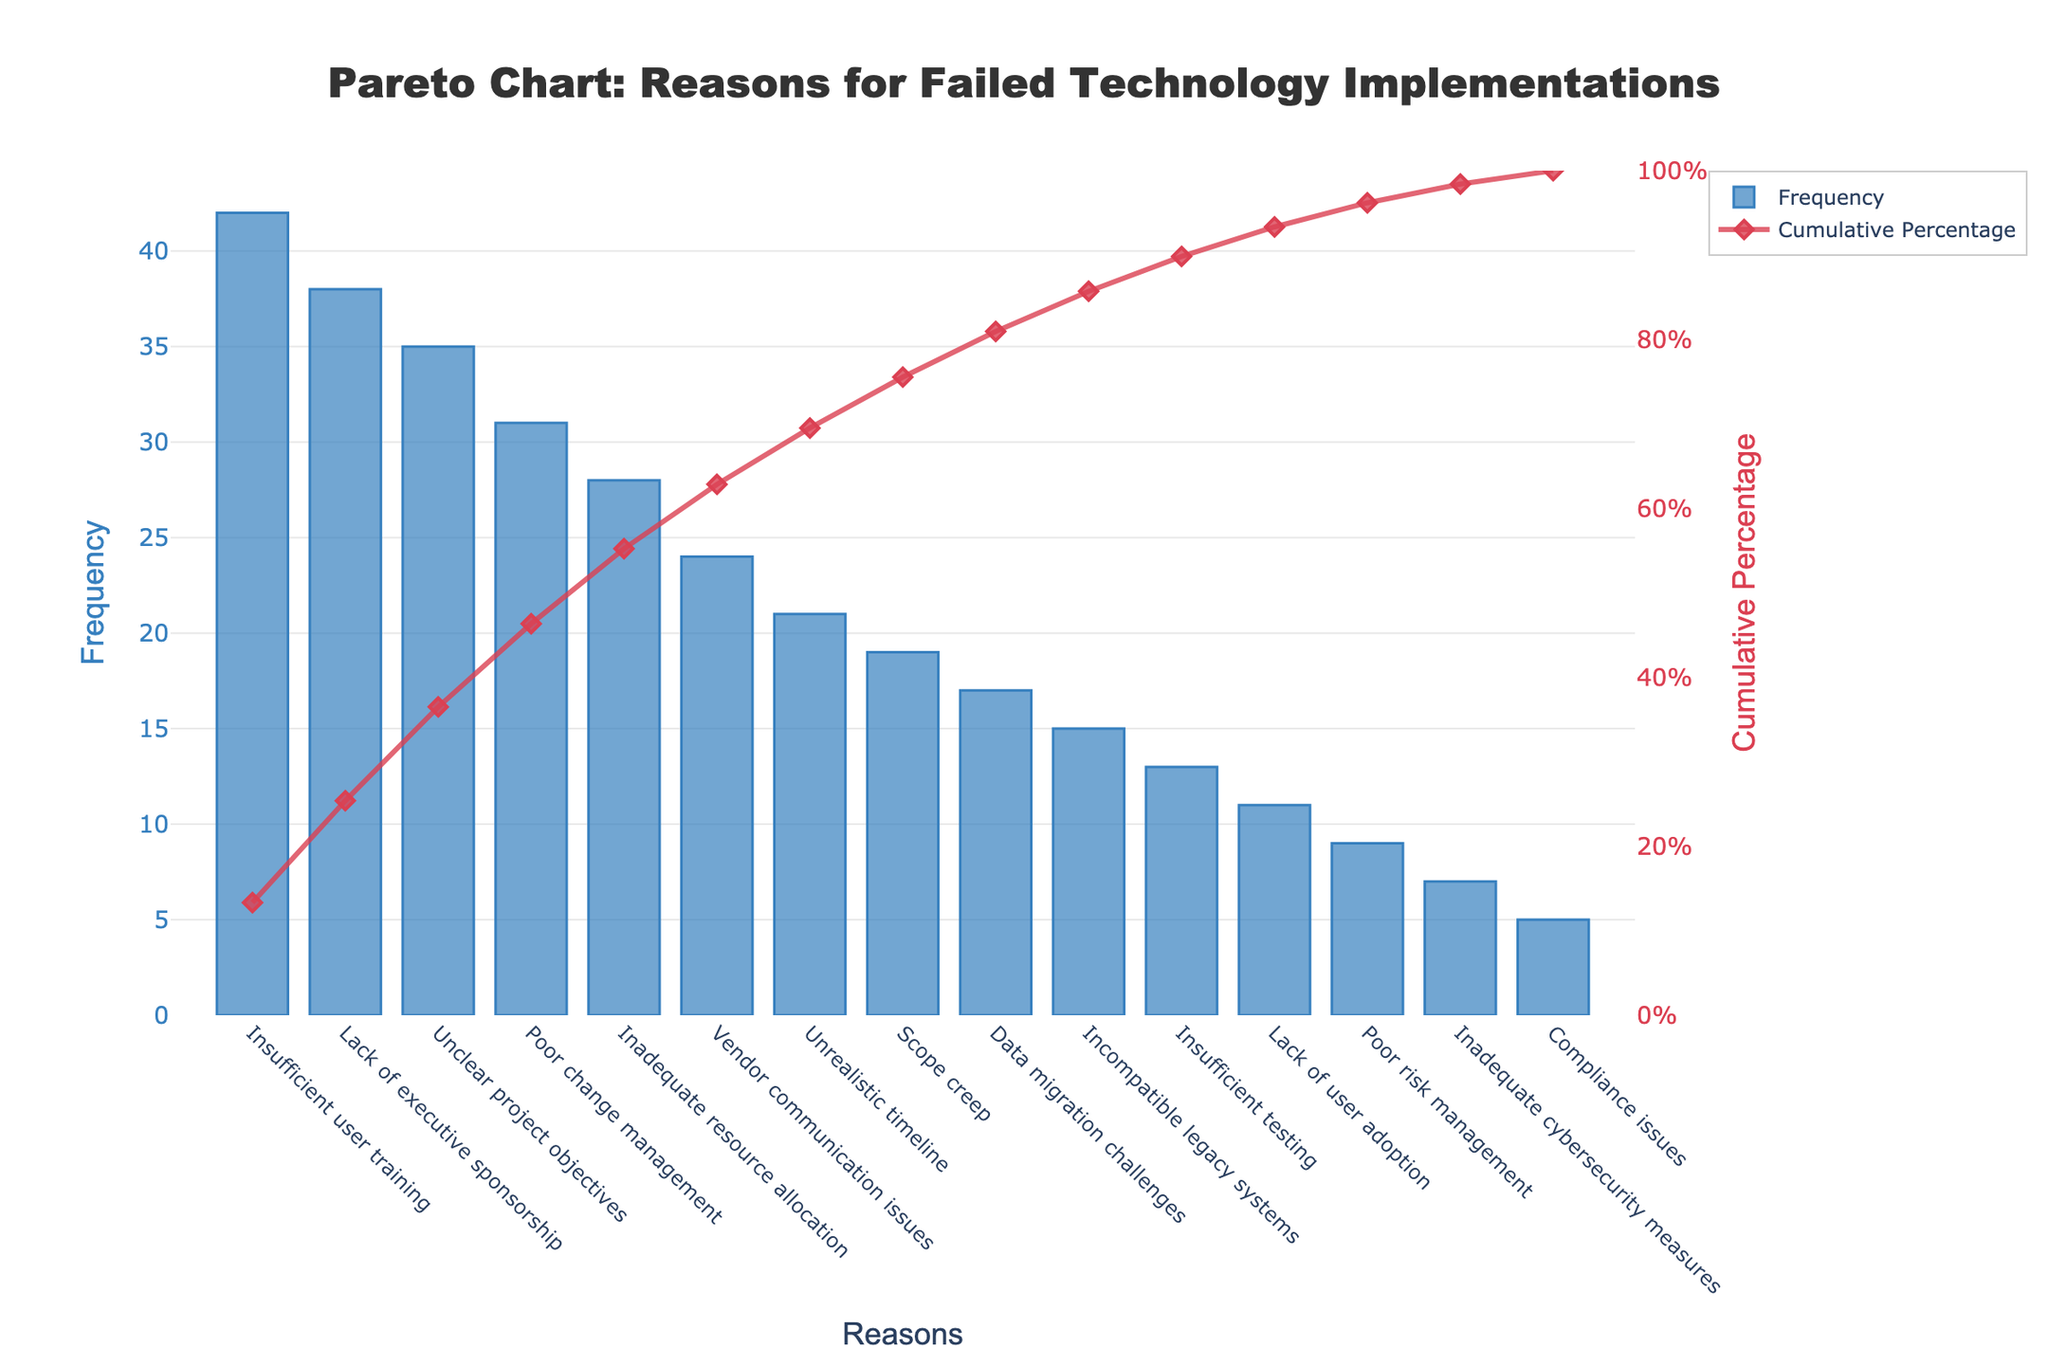What is the title of the chart? The title is prominently displayed at the top center of the chart. It reads "Pareto Chart: Reasons for Failed Technology Implementations".
Answer: Pareto Chart: Reasons for Failed Technology Implementations Which reason has the highest frequency? The first bar on the x-axis represents "Insufficient user training", which has the highest frequency.
Answer: Insufficient user training What is the cumulative percentage for "Poor change management"? "Poor change management" has a specific marker on the line chart, and it's next to "Unclear project objectives". Its cumulative percentage can be directly read from this marker, which is approximately 69%.
Answer: ~69% How does the frequency of "Vendor communication issues" compare to "Unrealistic timeline"? "Vendor communication issues" (24) is slightly higher than "Unrealistic timeline" (21).
Answer: Vendor communication issues is higher What percentage of reasons account for up to "Inadequate resource allocation"? Summing frequencies up to "Inadequate resource allocation" and looking at the cumulative percentage for clarity, the cumulative percentage here is approximately 85%. This means these reasons alone sum up almost 85% of the issues.
Answer: ~85% What is the axis title of the secondary y-axis? The secondary y-axis title, found on its right side, is "Cumulative Percentage".
Answer: Cumulative Percentage How many reasons have a frequency between 10 and 20? From the bars representing data points, "Scope creep" (19), "Data migration challenges" (17), "Incompatible legacy systems" (15), "Insufficient testing" (13), and "Lack of user adoption" (11) all fall within this range. There are 5 reasons in this frequency range.
Answer: 5 What is the color used for the bars in the chart? The bars in the chart are represented in a shade of blue, specifically a soft blue color with borders.
Answer: Blue Comparing "Compliance issues" and "Insufficient testing", what is their difference in frequency? The frequencies for "Compliance issues" (5) and "Insufficient testing" (13) are different by 8 units.
Answer: 8 What is the cumulative percentage after the first three most frequent reasons? "Insufficient user training", "Lack of executive sponsorship", and "Unclear project objectives" together add up to a cumulative percentage of approximately 57%.
Answer: ~57% 